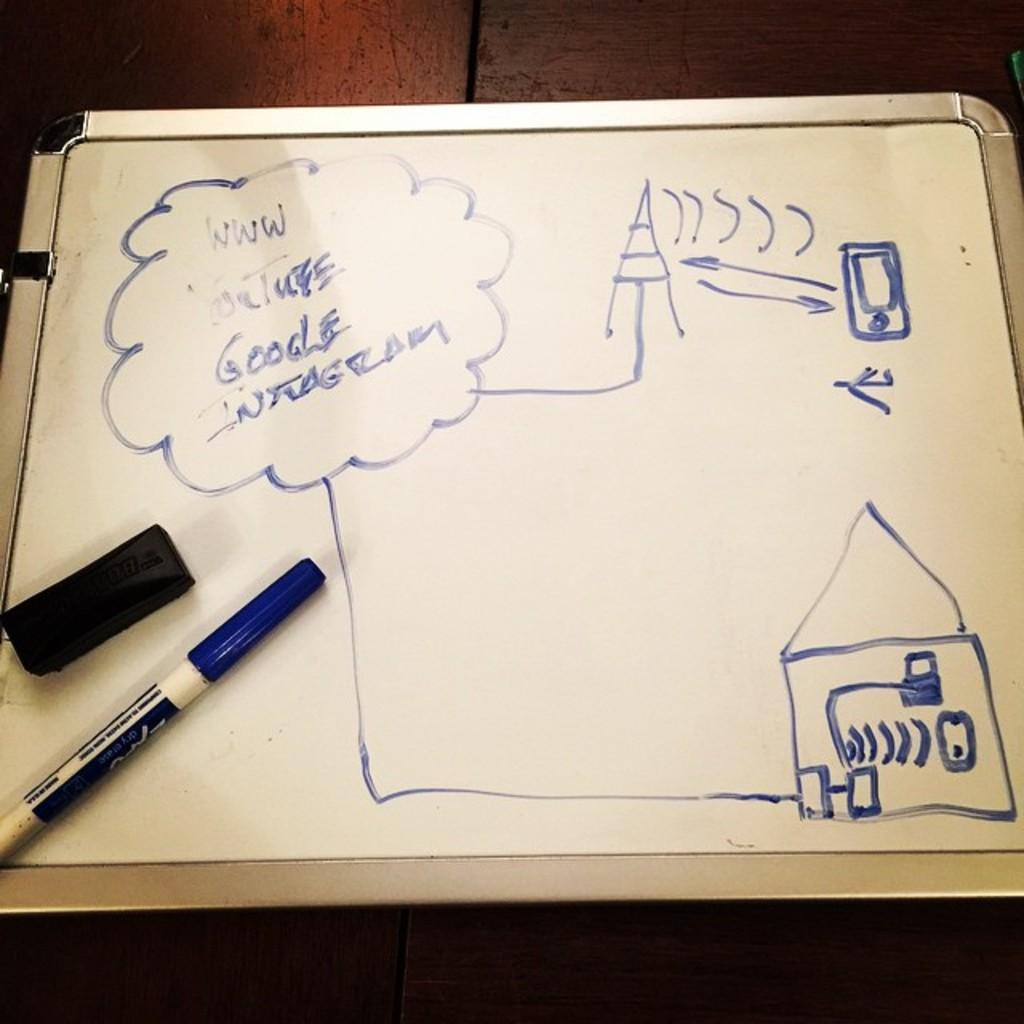<image>
Describe the image concisely. A white board with a drawing on it and the words YouTube, Google and Instagram in the corner. 